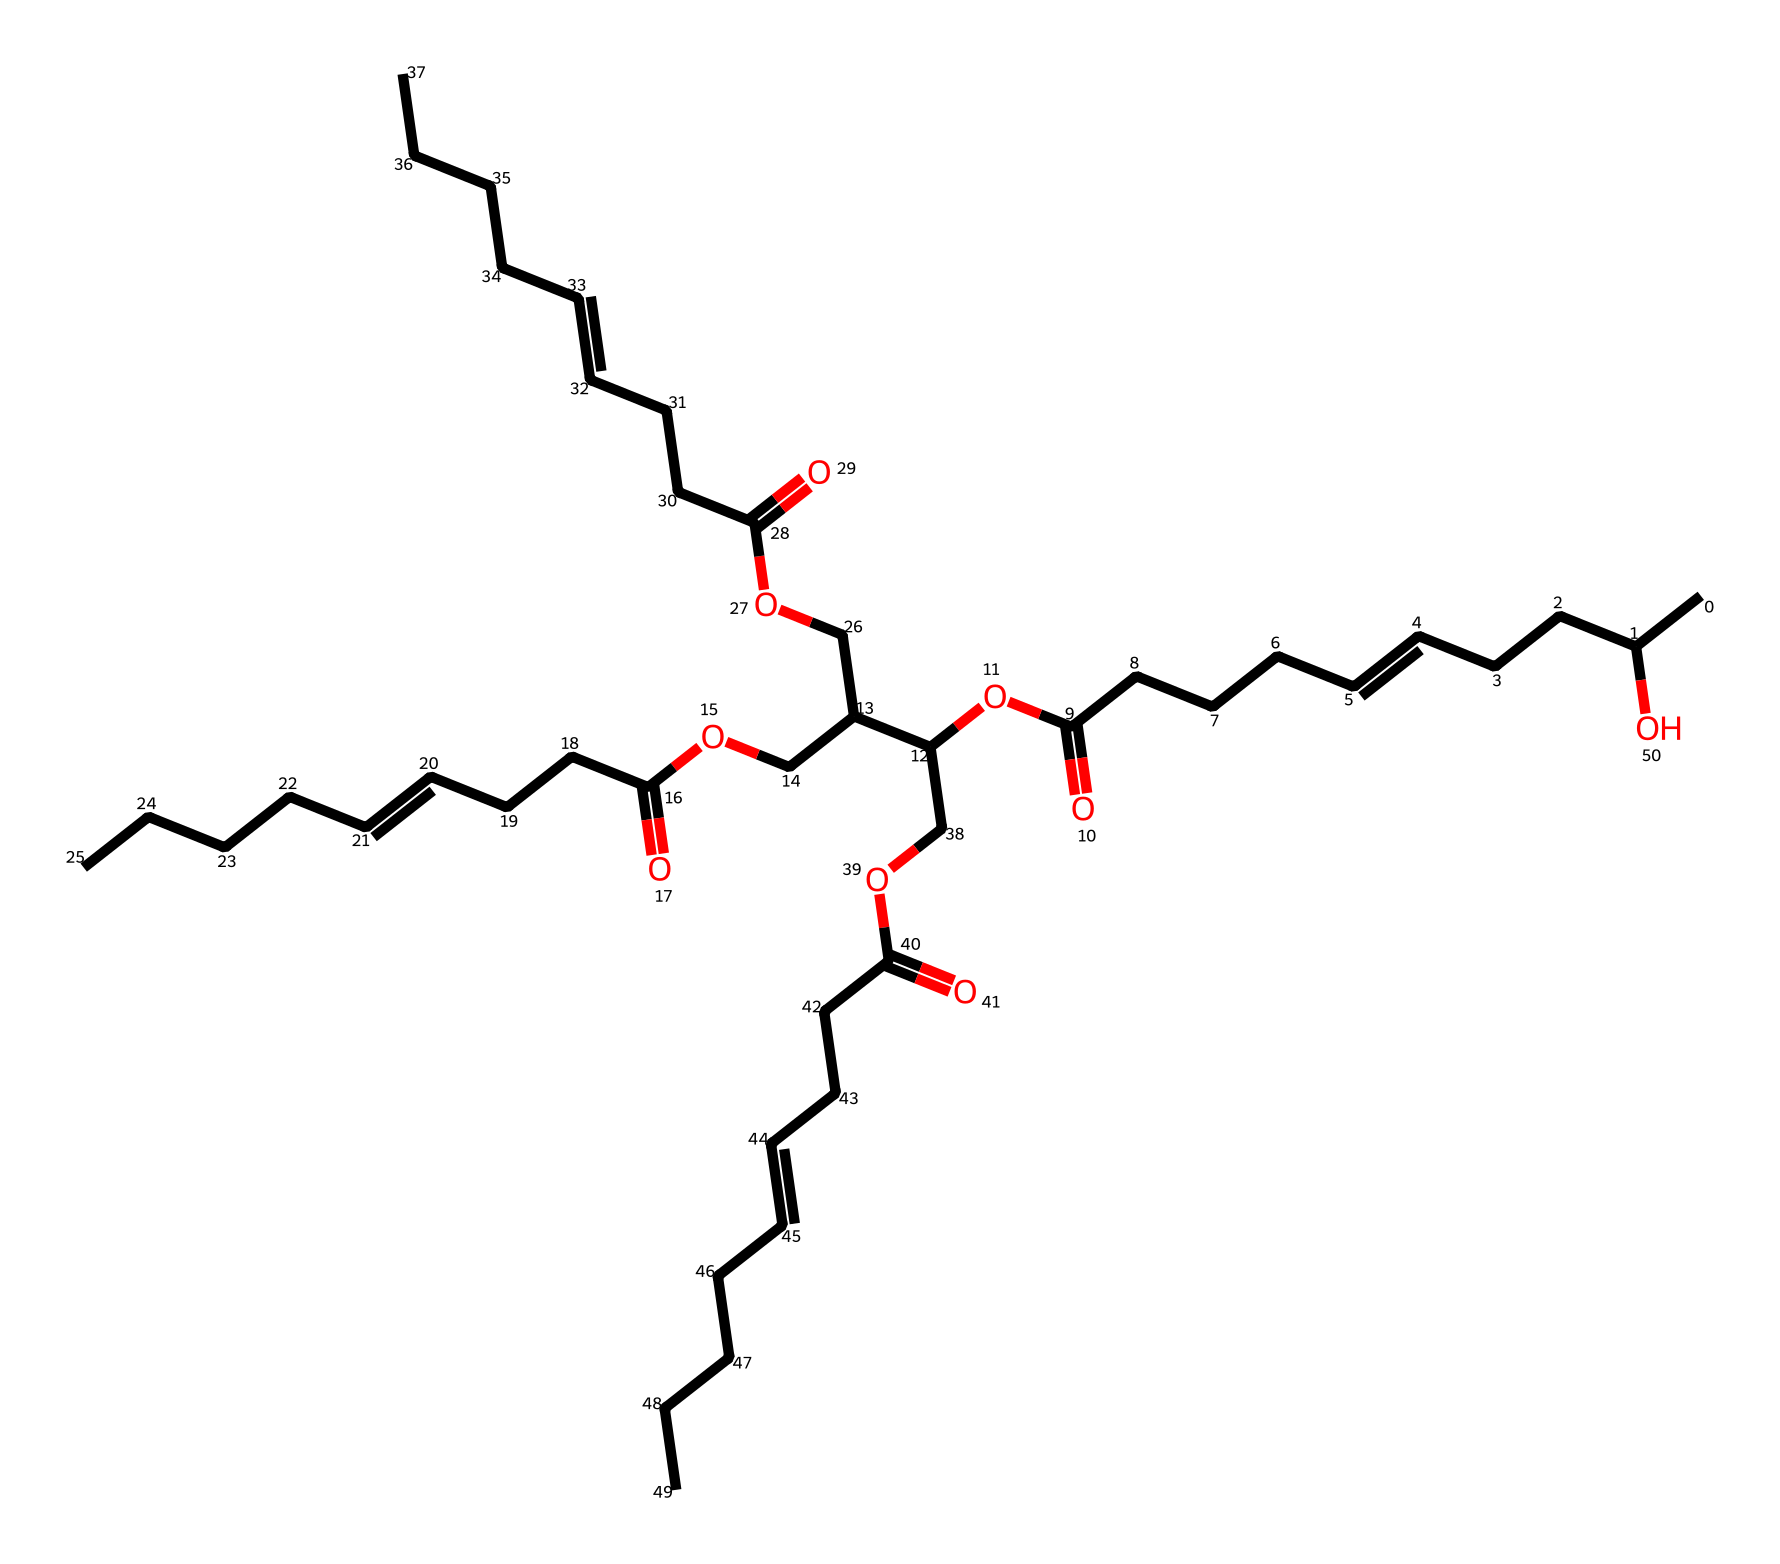What is the base fat in this chemical representation? The chemical structure includes long hydrocarbon chains with hydroxyl groups, indicating it is derived from vegetable oils, specifically castor oil, which is known for its ricinoleic acid content.
Answer: castor oil How many carbon atoms are present in the structure? By analyzing the chemical structure’s backbone, I counted a total of 34 carbon atoms present in the long hydrocarbon chains and additional functional groups combined.
Answer: 34 What functional group is evident in this structure? The chemical contains multiple ester groups (from the O=C-O bonds), indicating it is a fatty acid derivative, typical in lubricants which enhance slipping and reduce friction.
Answer: ester What is the primary use of castor oil in manufacturing processes? Castor oil is primarily used for its lubricating properties, thanks to its unique molecular arrangement which allows it to reduce friction in mechanical processes, making it essential in 19th-century lubrication.
Answer: lubrication How many ester groups are identified in this chemical? The structure contains three ester functional groups, each represented by regions where a carbonyl (C=O) is connected to an oxygen which is further attached to a carbon chain, signifying its properties as a lubricant.
Answer: three Does this chemical contain any hydroxyl groups? Yes, there are several hydroxyl (-OH) groups in the structure, specifically attached to some carbon chains that contribute to its chemical reactivity and lubricating characteristics.
Answer: yes 